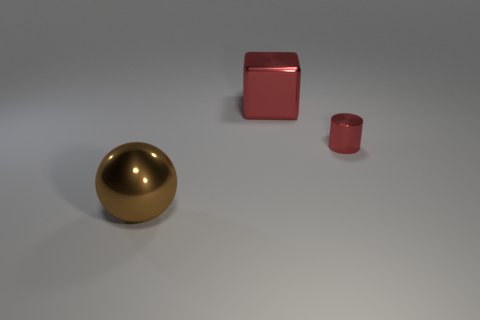Is the number of red cylinders in front of the large brown shiny sphere greater than the number of big brown metal things that are behind the big red object?
Keep it short and to the point. No. What number of objects are the same size as the brown sphere?
Provide a succinct answer. 1. Are there fewer tiny shiny objects that are behind the red shiny cylinder than brown metallic things that are to the left of the brown thing?
Provide a succinct answer. No. Is there another shiny thing that has the same shape as the brown object?
Keep it short and to the point. No. Is the shape of the big red shiny object the same as the small red thing?
Provide a short and direct response. No. What number of large objects are red shiny balls or red shiny cylinders?
Offer a terse response. 0. Are there more small shiny things than objects?
Keep it short and to the point. No. What size is the brown ball that is the same material as the big block?
Offer a terse response. Large. Do the red metal object behind the small red cylinder and the metal thing in front of the small cylinder have the same size?
Your answer should be compact. Yes. How many things are either objects that are in front of the big red cube or small purple things?
Offer a terse response. 2. 